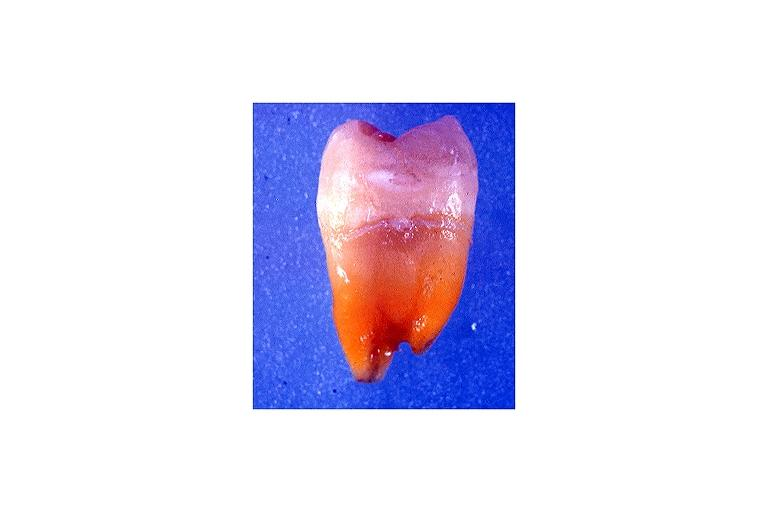what does this image show?
Answer the question using a single word or phrase. Tetracycline induced discoloration 